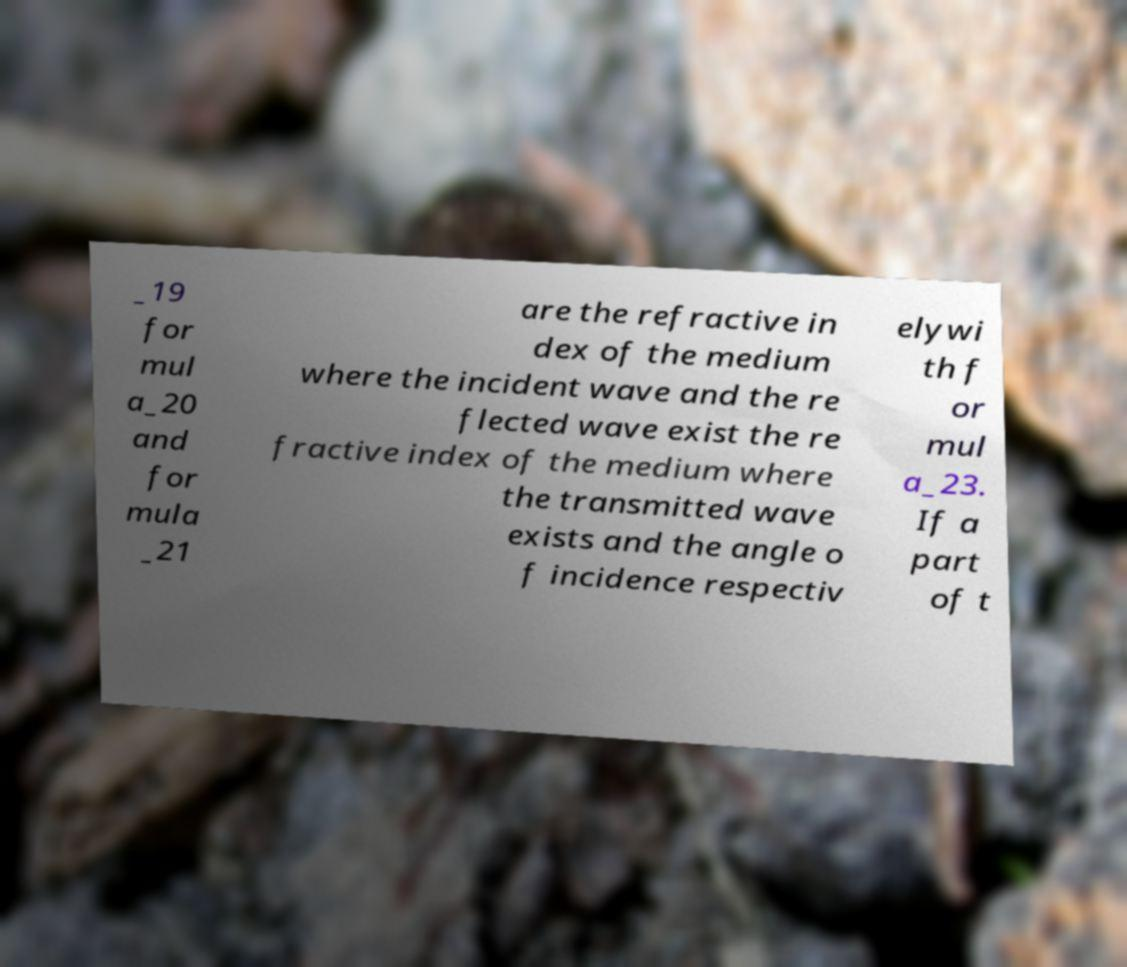Please read and relay the text visible in this image. What does it say? _19 for mul a_20 and for mula _21 are the refractive in dex of the medium where the incident wave and the re flected wave exist the re fractive index of the medium where the transmitted wave exists and the angle o f incidence respectiv elywi th f or mul a_23. If a part of t 